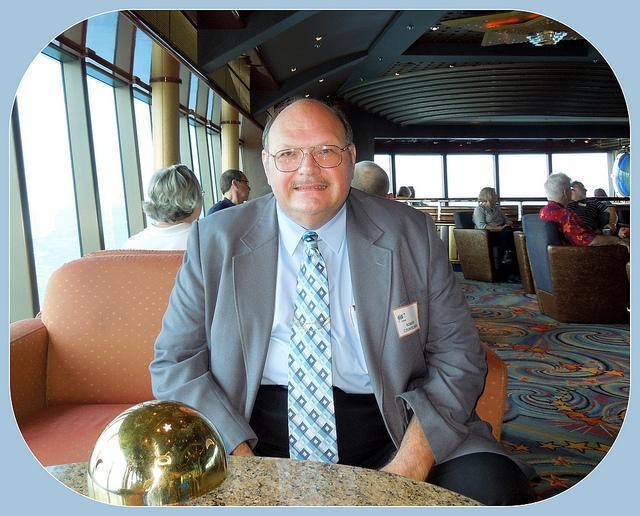How many couches are there?
Give a very brief answer. 2. How many people are in the photo?
Give a very brief answer. 3. How many chairs can you see?
Give a very brief answer. 2. 